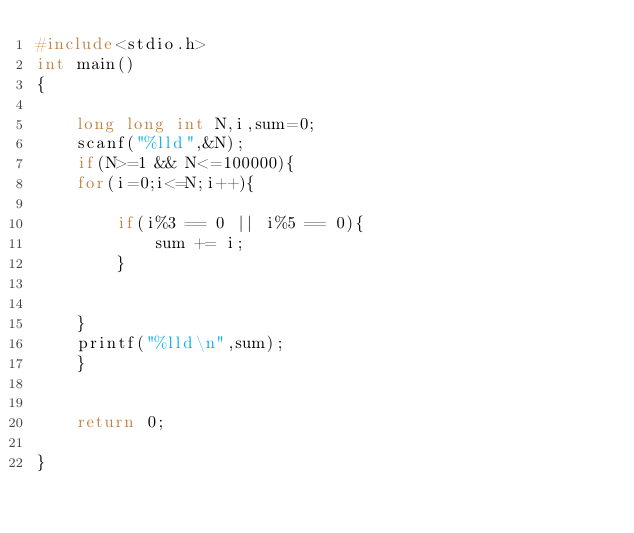Convert code to text. <code><loc_0><loc_0><loc_500><loc_500><_C_>#include<stdio.h>
int main()
{

    long long int N,i,sum=0;
    scanf("%lld",&N);
    if(N>=1 && N<=100000){
    for(i=0;i<=N;i++){

        if(i%3 == 0 || i%5 == 0){
            sum += i;
        }


    }
    printf("%lld\n",sum);
    }


    return 0;

}
</code> 